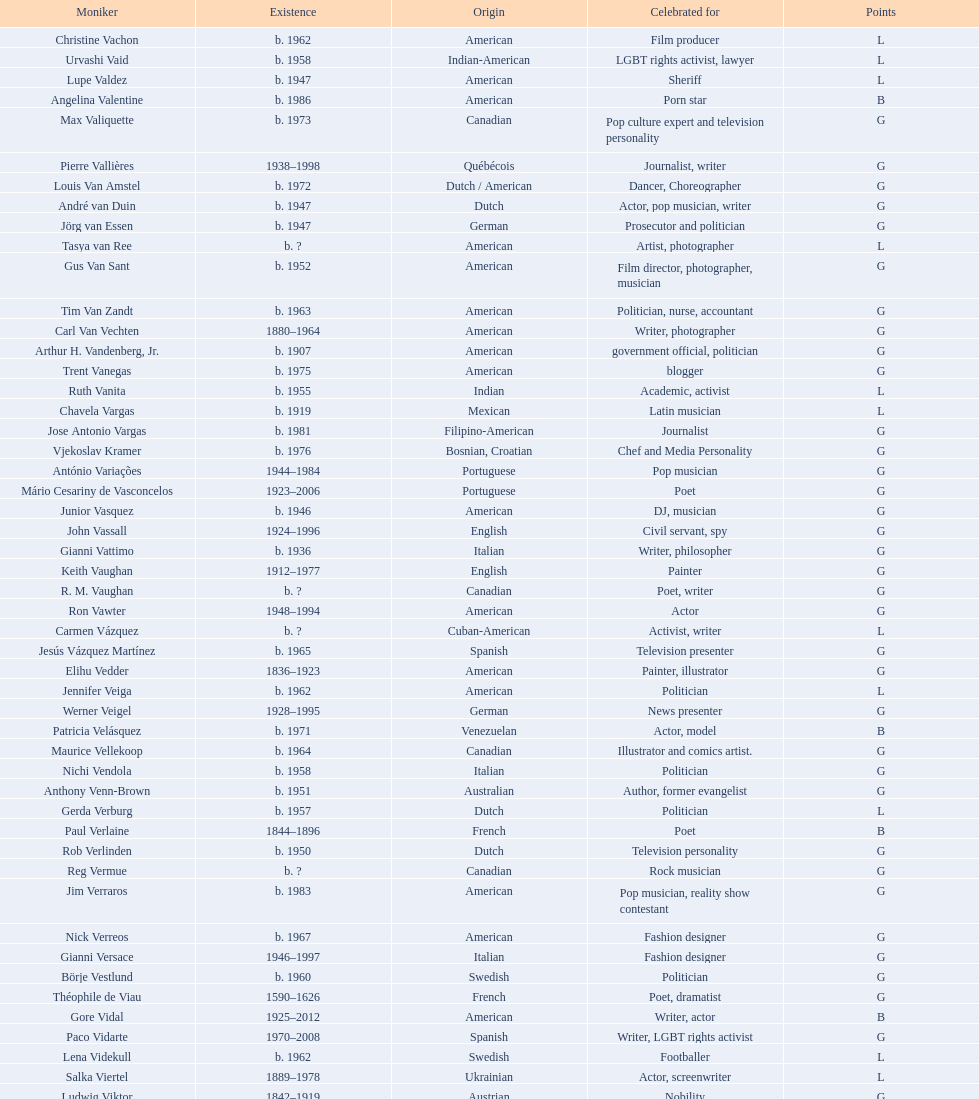Patricia velasquez and ron vawter both had what career? Actor. 